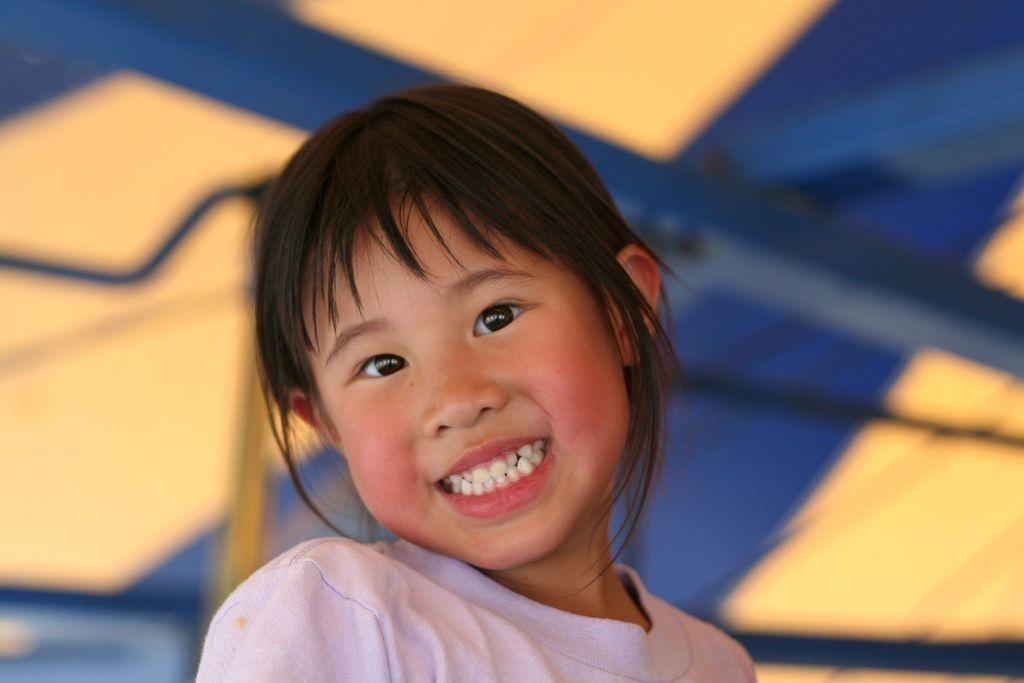Who is present in the image? There is a girl in the image. What is the girl's expression in the image? The girl is smiling in the image. What can be seen in the background of the image? There is a wall in the background of the image. What type of magic is the girl performing in the image? There is no magic or any indication of magical activity in the image; the girl is simply smiling. 